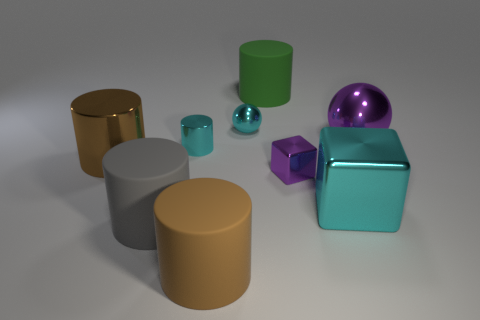Subtract all brown matte cylinders. How many cylinders are left? 4 Subtract all gray balls. How many brown cylinders are left? 2 Subtract all cyan cylinders. How many cylinders are left? 4 Subtract 1 cylinders. How many cylinders are left? 4 Add 1 small green things. How many objects exist? 10 Subtract all purple cylinders. Subtract all brown cubes. How many cylinders are left? 5 Subtract all spheres. How many objects are left? 7 Add 4 brown cylinders. How many brown cylinders are left? 6 Add 5 tiny blue things. How many tiny blue things exist? 5 Subtract 0 green blocks. How many objects are left? 9 